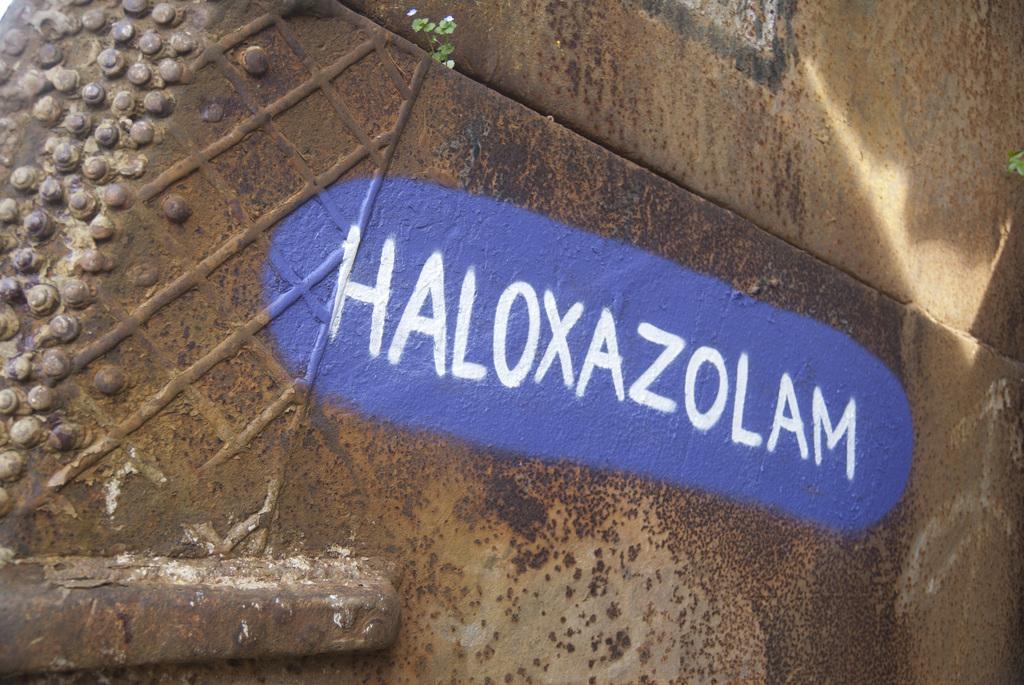In one or two sentences, can you explain what this image depicts? In the picture there is some name written with white paint on a purple background on a surface. 